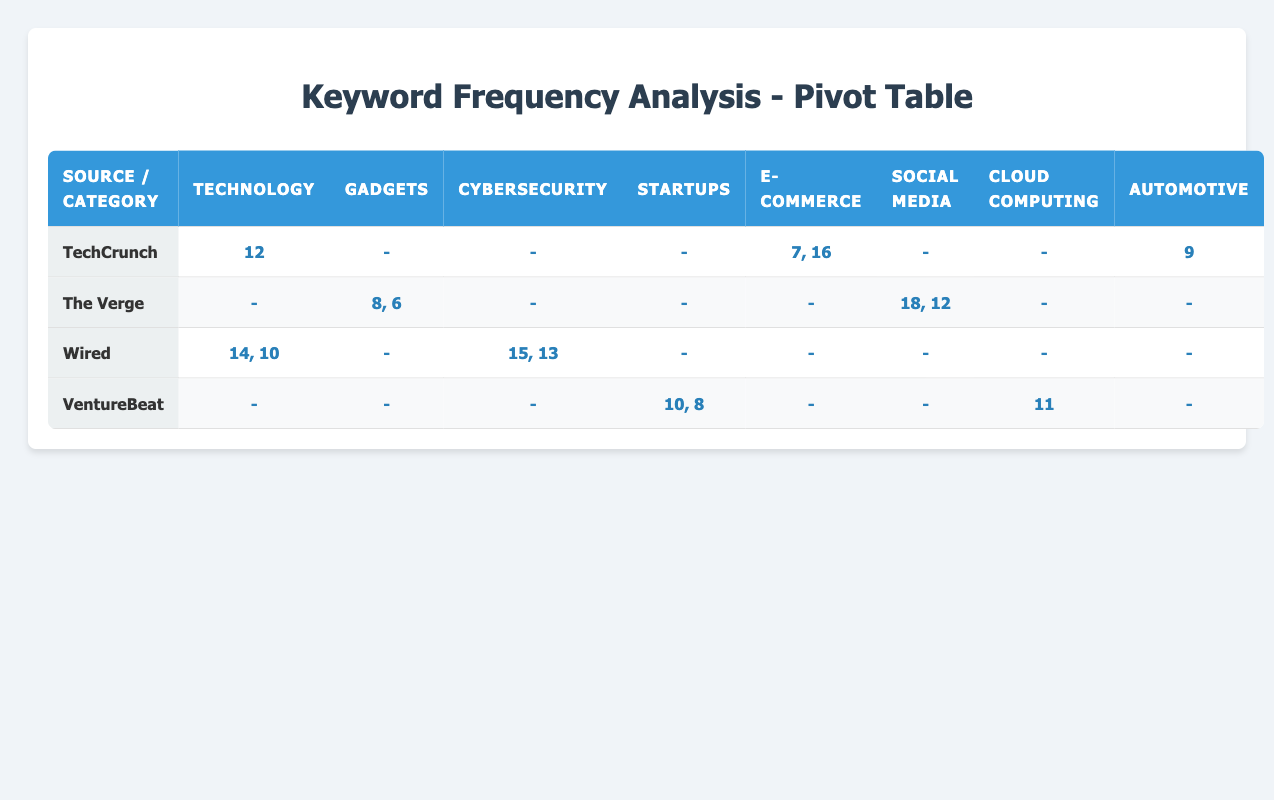What is the total frequency of keywords mentioned by TechCrunch in the Technology category? TechCrunch has a frequency of 12 for the keyword "artificial intelligence" in the Technology category. As there are no other entries for TechCrunch in this category, the total frequency is 12.
Answer: 12 Which article source has the highest keyword frequency in the Gadgets category? In the Gadgets category, The Verge has entries with frequencies of 8 and 6. The highest frequency is 8 for the keyword "smartphone."
Answer: The Verge Is there any source that has mentioned keywords in the Cloud Computing category? Upon reviewing the table, VentureBeat has a frequency of 11 for the keyword "AWS" in the Cloud Computing category. Therefore, the answer is yes.
Answer: Yes What is the sum of frequencies for Wired in the Cybersecurity category? Wired mentions "ransomware" with a frequency of 15 and "data breach" with a frequency of 13, leading to a total of 15 + 13 = 28.
Answer: 28 How many keywords has TechCrunch mentioned in the E-commerce category? TechCrunch has two keywords listed in the E-commerce category, "online shopping" with a frequency of 7 and "Amazon" with a frequency of 16.
Answer: 2 What is the average frequency of keywords across all sources in the Startups category? There are two frequencies in the Startups category: 10 for "funding" from VentureBeat and 8 for "Series A" also from VentureBeat. The average is (10 + 8) / 2 = 9.
Answer: 9 Which category has the lowest total frequency? Calculating the total frequencies of each category reveals that Gadgets has the lowest total with frequencies of 8 and 6, resulting in 8 + 6 = 14. Other categories have higher totals.
Answer: Gadgets Did The Verge mention keywords in the Automotive category? Checking the Automotive category for The Verge reveals no entries, hence the answer is no.
Answer: No 